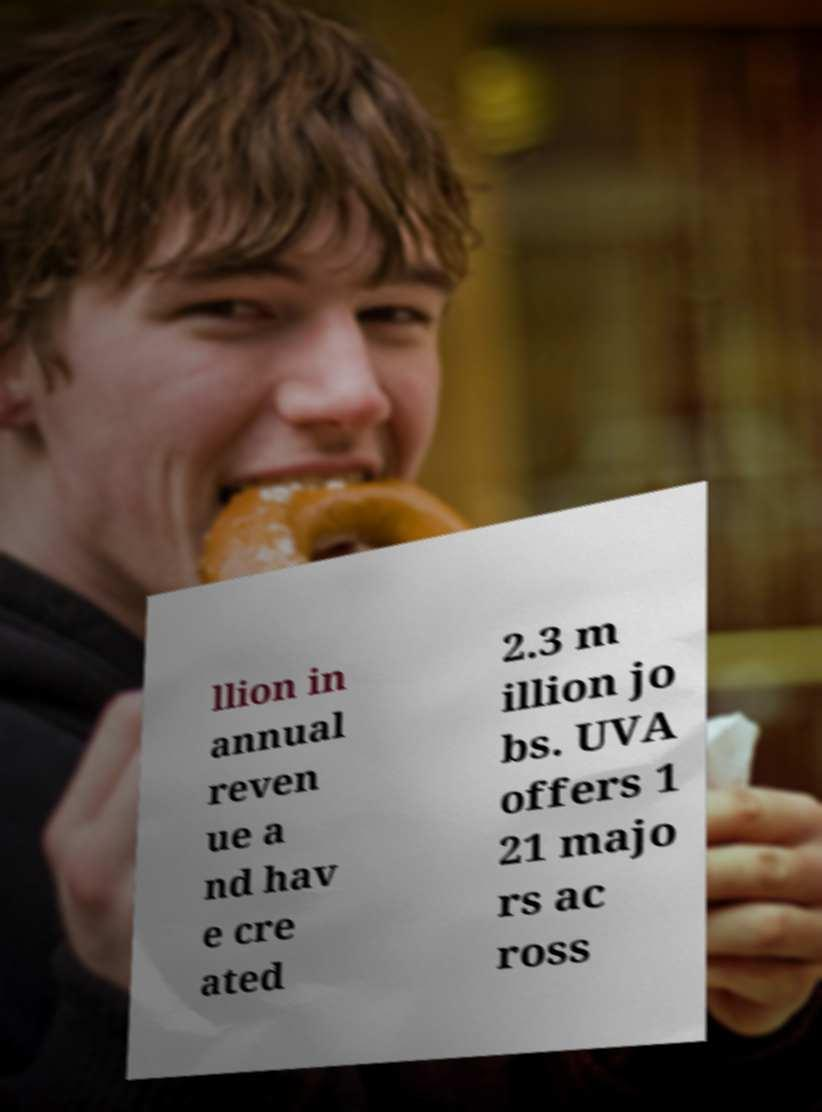Can you read and provide the text displayed in the image?This photo seems to have some interesting text. Can you extract and type it out for me? llion in annual reven ue a nd hav e cre ated 2.3 m illion jo bs. UVA offers 1 21 majo rs ac ross 